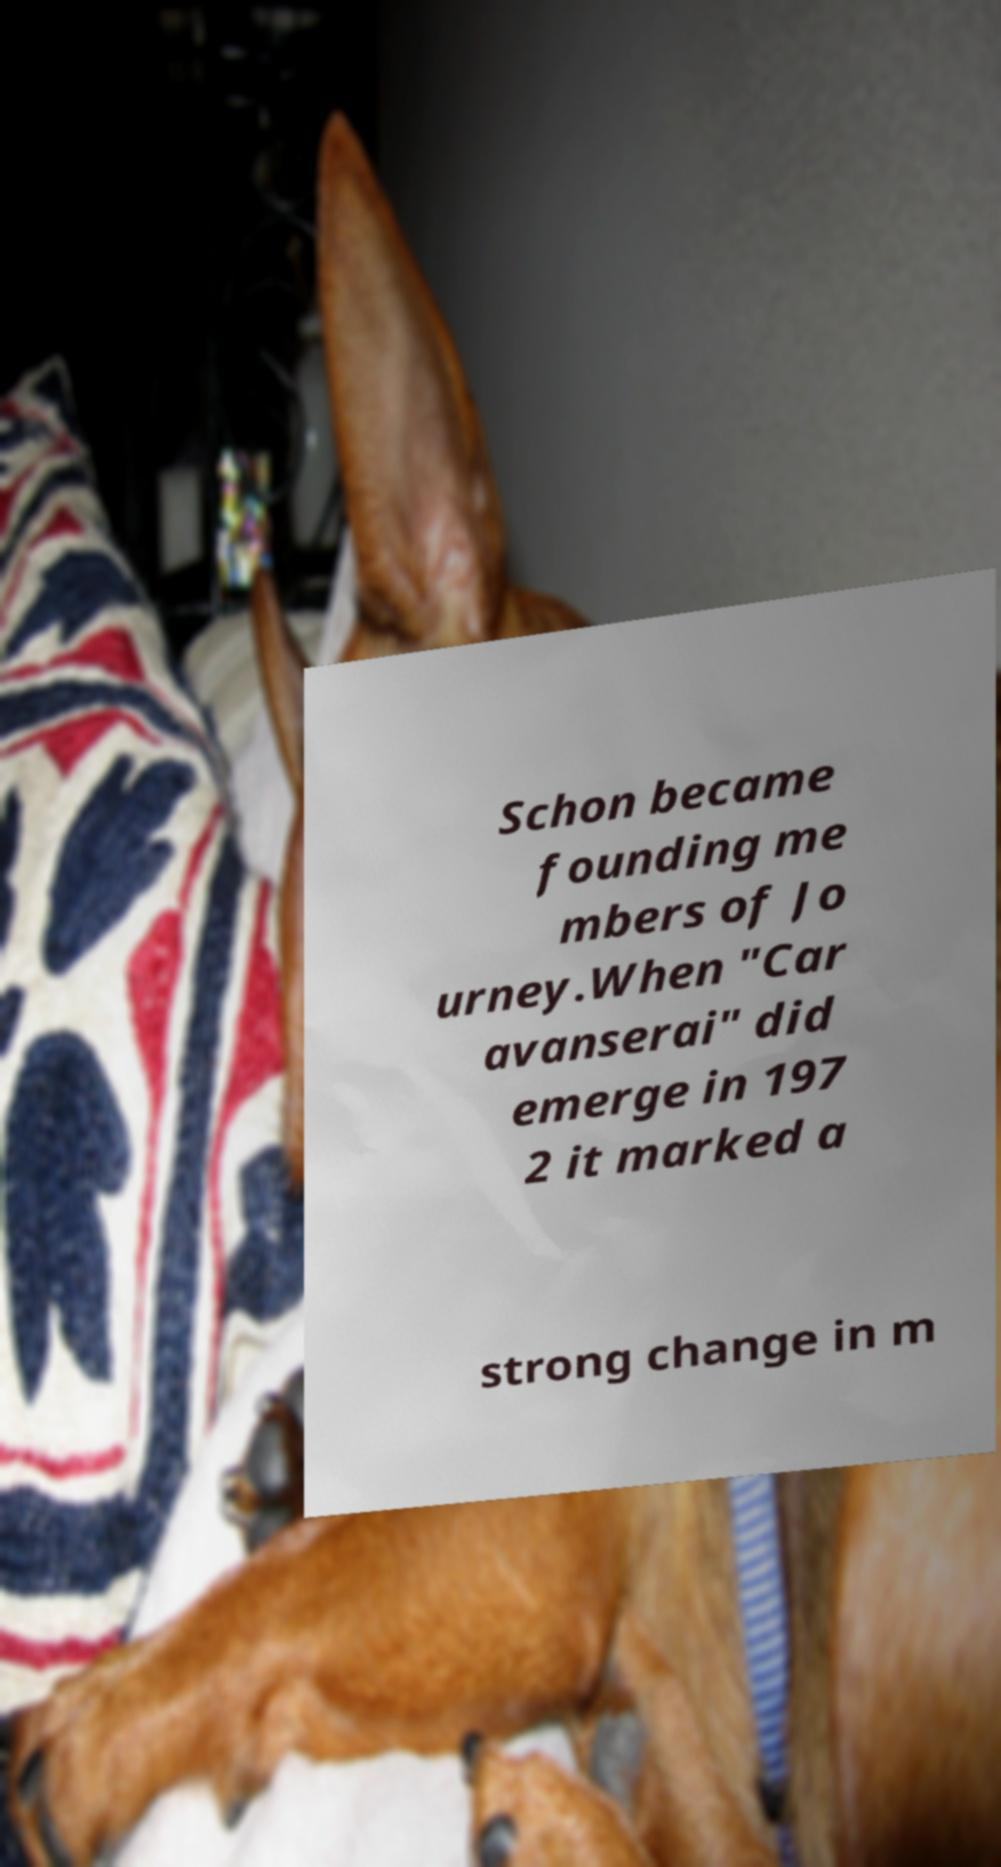I need the written content from this picture converted into text. Can you do that? Schon became founding me mbers of Jo urney.When "Car avanserai" did emerge in 197 2 it marked a strong change in m 